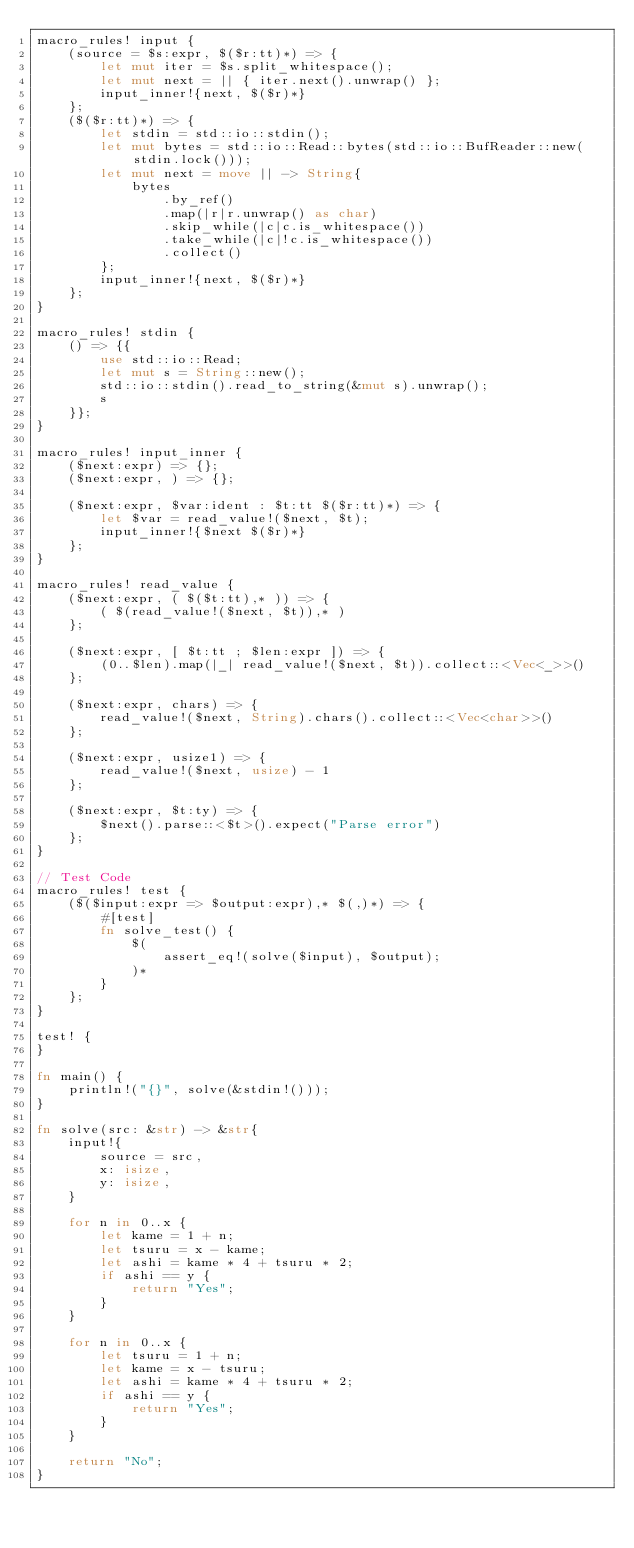<code> <loc_0><loc_0><loc_500><loc_500><_Rust_>macro_rules! input {
    (source = $s:expr, $($r:tt)*) => {
        let mut iter = $s.split_whitespace();
        let mut next = || { iter.next().unwrap() };
        input_inner!{next, $($r)*}
    };
    ($($r:tt)*) => {
        let stdin = std::io::stdin();
        let mut bytes = std::io::Read::bytes(std::io::BufReader::new(stdin.lock()));
        let mut next = move || -> String{
            bytes
                .by_ref()
                .map(|r|r.unwrap() as char)
                .skip_while(|c|c.is_whitespace())
                .take_while(|c|!c.is_whitespace())
                .collect()
        };
        input_inner!{next, $($r)*}
    };
}

macro_rules! stdin {
    () => {{
        use std::io::Read;
        let mut s = String::new();
        std::io::stdin().read_to_string(&mut s).unwrap();
        s
    }};
}

macro_rules! input_inner {
    ($next:expr) => {};
    ($next:expr, ) => {};

    ($next:expr, $var:ident : $t:tt $($r:tt)*) => {
        let $var = read_value!($next, $t);
        input_inner!{$next $($r)*}
    };
}

macro_rules! read_value {
    ($next:expr, ( $($t:tt),* )) => {
        ( $(read_value!($next, $t)),* )
    };

    ($next:expr, [ $t:tt ; $len:expr ]) => {
        (0..$len).map(|_| read_value!($next, $t)).collect::<Vec<_>>()
    };

    ($next:expr, chars) => {
        read_value!($next, String).chars().collect::<Vec<char>>()
    };

    ($next:expr, usize1) => {
        read_value!($next, usize) - 1
    };

    ($next:expr, $t:ty) => {
        $next().parse::<$t>().expect("Parse error")
    };
}

// Test Code
macro_rules! test {
    ($($input:expr => $output:expr),* $(,)*) => {
        #[test]
        fn solve_test() {
            $(
                assert_eq!(solve($input), $output);
            )*
        }
    };
}

test! {
}

fn main() {
    println!("{}", solve(&stdin!()));
}

fn solve(src: &str) -> &str{
    input!{
        source = src,
        x: isize,
        y: isize,
    }

    for n in 0..x {
        let kame = 1 + n;
        let tsuru = x - kame;
        let ashi = kame * 4 + tsuru * 2;
        if ashi == y {
            return "Yes";
        }
    }

    for n in 0..x {
        let tsuru = 1 + n;
        let kame = x - tsuru;
        let ashi = kame * 4 + tsuru * 2;
        if ashi == y {
            return "Yes";
        }
    }

    return "No";
}
</code> 